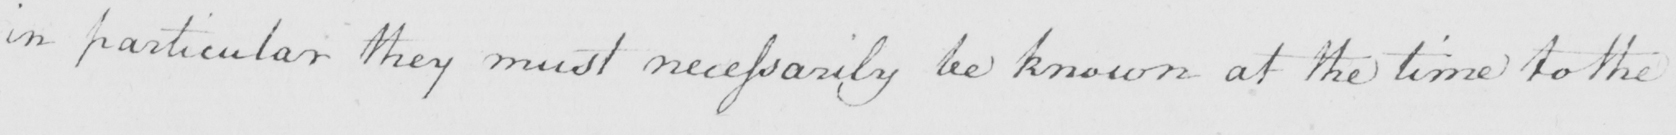Please transcribe the handwritten text in this image. in particular they must necessarily be known at the time to the 